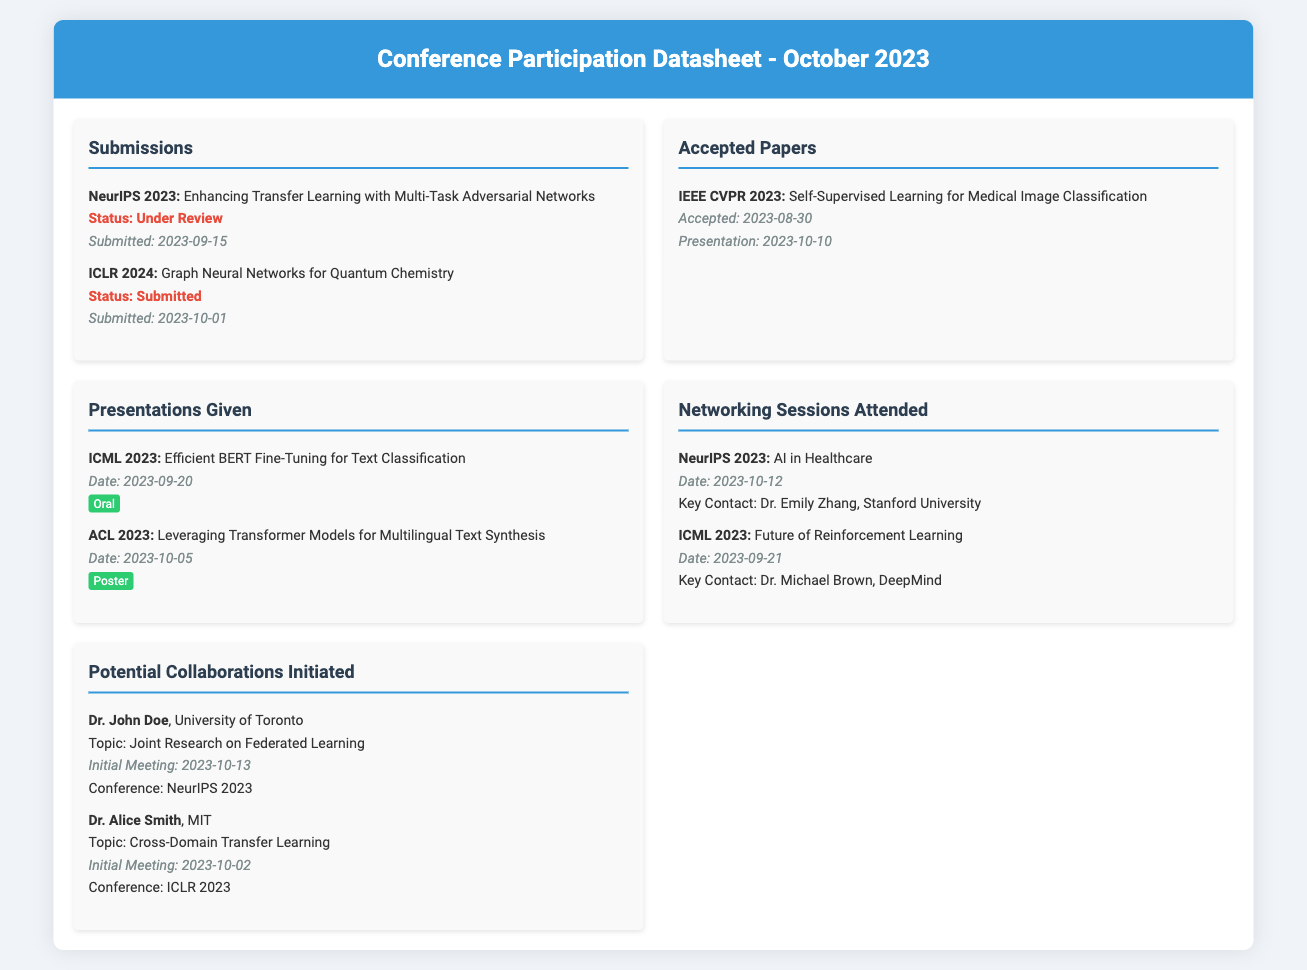What is the title of the accepted paper at IEEE CVPR 2023? The title of the accepted paper is mentioned in the "Accepted Papers" section.
Answer: Self-Supervised Learning for Medical Image Classification Who is a key contact from the AI in Healthcare networking session? The document lists Dr. Emily Zhang as the key contact for the AI in Healthcare networking session under "Networking Sessions Attended."
Answer: Dr. Emily Zhang How many submissions were made in October 2023? The document details two submissions, one in September and one in October.
Answer: 1 What was the presentation type for the ICML 2023 presentation? The presentation type is specified in the "Presentations Given" section for the ICML 2023 entry.
Answer: Oral What is the date of the initial meeting with Dr. John Doe? The date can be found in the "Potential Collaborations Initiated" section next to Dr. John Doe's name.
Answer: 2023-10-13 How many potential collaborations were initiated? The document lists two collaborations under the "Potential Collaborations Initiated" section.
Answer: 2 What is the submission status of the paper for NeurIPS 2023? The status is stated in the "Submissions" section for NeurIPS 2023.
Answer: Under Review What was the date of the presentation at ACL 2023? This date is recorded in the "Presentations Given" section next to the title for ACL 2023.
Answer: 2023-10-05 